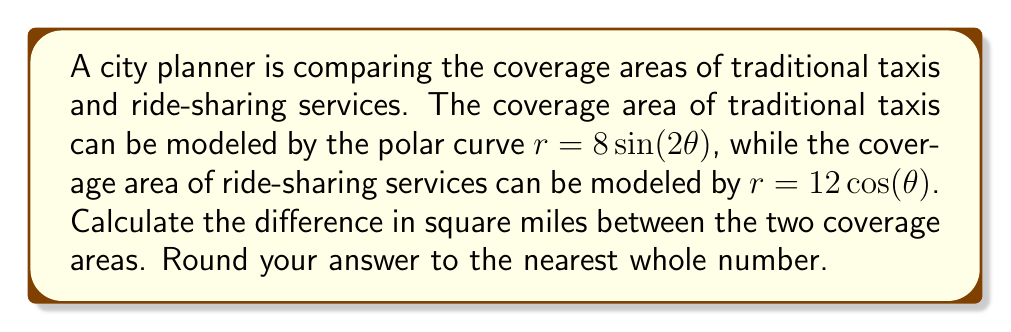Give your solution to this math problem. To solve this problem, we need to follow these steps:

1) First, let's recall the formula for the area enclosed by a polar curve:
   $A = \frac{1}{2} \int_{0}^{2\pi} r^2 d\theta$

2) For traditional taxis: $r = 8\sin(2\theta)$
   Area = $\frac{1}{2} \int_{0}^{2\pi} (8\sin(2\theta))^2 d\theta$
        = $32 \int_{0}^{2\pi} \sin^2(2\theta) d\theta$
        = $32 \cdot \frac{1}{2} \int_{0}^{2\pi} (1 - \cos(4\theta)) d\theta$
        = $16 [\theta - \frac{1}{4}\sin(4\theta)]_{0}^{2\pi}$
        = $16 [2\pi - 0] = 32\pi$ square miles

3) For ride-sharing services: $r = 12\cos(\theta)$
   Area = $\frac{1}{2} \int_{0}^{2\pi} (12\cos(\theta))^2 d\theta$
        = $72 \int_{0}^{2\pi} \cos^2(\theta) d\theta$
        = $72 \cdot \frac{1}{2} \int_{0}^{2\pi} (1 + \cos(2\theta)) d\theta$
        = $36 [\theta + \frac{1}{2}\sin(2\theta)]_{0}^{2\pi}$
        = $36 [2\pi - 0] = 72\pi$ square miles

4) The difference in coverage areas:
   $72\pi - 32\pi = 40\pi \approx 125.66$ square miles

5) Rounding to the nearest whole number: 126 square miles
Answer: 126 square miles 